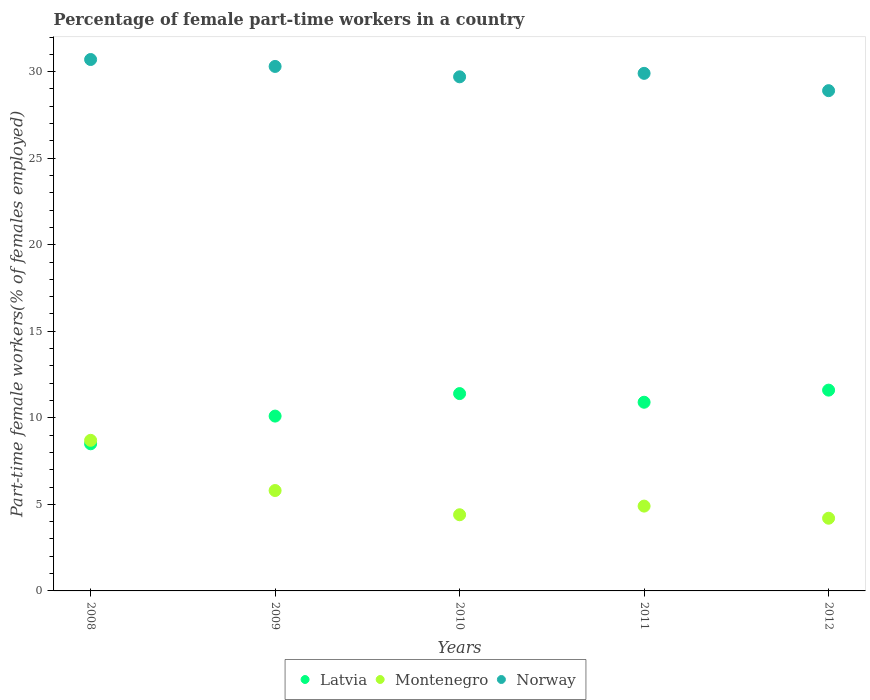How many different coloured dotlines are there?
Keep it short and to the point. 3. Is the number of dotlines equal to the number of legend labels?
Offer a terse response. Yes. What is the percentage of female part-time workers in Latvia in 2012?
Your answer should be compact. 11.6. Across all years, what is the maximum percentage of female part-time workers in Latvia?
Give a very brief answer. 11.6. Across all years, what is the minimum percentage of female part-time workers in Latvia?
Ensure brevity in your answer.  8.5. In which year was the percentage of female part-time workers in Norway minimum?
Give a very brief answer. 2012. What is the total percentage of female part-time workers in Latvia in the graph?
Make the answer very short. 52.5. What is the difference between the percentage of female part-time workers in Norway in 2008 and that in 2011?
Give a very brief answer. 0.8. What is the difference between the percentage of female part-time workers in Montenegro in 2011 and the percentage of female part-time workers in Latvia in 2012?
Give a very brief answer. -6.7. What is the average percentage of female part-time workers in Montenegro per year?
Provide a short and direct response. 5.6. In the year 2008, what is the difference between the percentage of female part-time workers in Norway and percentage of female part-time workers in Latvia?
Your response must be concise. 22.2. What is the ratio of the percentage of female part-time workers in Montenegro in 2008 to that in 2009?
Offer a terse response. 1.5. Is the difference between the percentage of female part-time workers in Norway in 2008 and 2012 greater than the difference between the percentage of female part-time workers in Latvia in 2008 and 2012?
Give a very brief answer. Yes. What is the difference between the highest and the second highest percentage of female part-time workers in Montenegro?
Your response must be concise. 2.9. What is the difference between the highest and the lowest percentage of female part-time workers in Latvia?
Your answer should be very brief. 3.1. Is the sum of the percentage of female part-time workers in Latvia in 2009 and 2010 greater than the maximum percentage of female part-time workers in Montenegro across all years?
Keep it short and to the point. Yes. Is it the case that in every year, the sum of the percentage of female part-time workers in Norway and percentage of female part-time workers in Montenegro  is greater than the percentage of female part-time workers in Latvia?
Provide a succinct answer. Yes. Is the percentage of female part-time workers in Latvia strictly greater than the percentage of female part-time workers in Montenegro over the years?
Provide a short and direct response. No. Is the percentage of female part-time workers in Norway strictly less than the percentage of female part-time workers in Montenegro over the years?
Offer a terse response. No. How many dotlines are there?
Your answer should be compact. 3. What is the difference between two consecutive major ticks on the Y-axis?
Keep it short and to the point. 5. Does the graph contain any zero values?
Provide a succinct answer. No. Does the graph contain grids?
Provide a short and direct response. No. Where does the legend appear in the graph?
Offer a terse response. Bottom center. How are the legend labels stacked?
Offer a terse response. Horizontal. What is the title of the graph?
Give a very brief answer. Percentage of female part-time workers in a country. What is the label or title of the Y-axis?
Give a very brief answer. Part-time female workers(% of females employed). What is the Part-time female workers(% of females employed) in Montenegro in 2008?
Offer a terse response. 8.7. What is the Part-time female workers(% of females employed) in Norway in 2008?
Ensure brevity in your answer.  30.7. What is the Part-time female workers(% of females employed) of Latvia in 2009?
Your answer should be very brief. 10.1. What is the Part-time female workers(% of females employed) in Montenegro in 2009?
Your answer should be very brief. 5.8. What is the Part-time female workers(% of females employed) in Norway in 2009?
Ensure brevity in your answer.  30.3. What is the Part-time female workers(% of females employed) in Latvia in 2010?
Offer a terse response. 11.4. What is the Part-time female workers(% of females employed) in Montenegro in 2010?
Your answer should be very brief. 4.4. What is the Part-time female workers(% of females employed) in Norway in 2010?
Make the answer very short. 29.7. What is the Part-time female workers(% of females employed) in Latvia in 2011?
Provide a short and direct response. 10.9. What is the Part-time female workers(% of females employed) of Montenegro in 2011?
Offer a very short reply. 4.9. What is the Part-time female workers(% of females employed) of Norway in 2011?
Provide a short and direct response. 29.9. What is the Part-time female workers(% of females employed) in Latvia in 2012?
Your response must be concise. 11.6. What is the Part-time female workers(% of females employed) in Montenegro in 2012?
Make the answer very short. 4.2. What is the Part-time female workers(% of females employed) in Norway in 2012?
Your answer should be compact. 28.9. Across all years, what is the maximum Part-time female workers(% of females employed) in Latvia?
Your response must be concise. 11.6. Across all years, what is the maximum Part-time female workers(% of females employed) of Montenegro?
Your answer should be compact. 8.7. Across all years, what is the maximum Part-time female workers(% of females employed) in Norway?
Keep it short and to the point. 30.7. Across all years, what is the minimum Part-time female workers(% of females employed) in Montenegro?
Ensure brevity in your answer.  4.2. Across all years, what is the minimum Part-time female workers(% of females employed) in Norway?
Offer a terse response. 28.9. What is the total Part-time female workers(% of females employed) of Latvia in the graph?
Make the answer very short. 52.5. What is the total Part-time female workers(% of females employed) of Montenegro in the graph?
Give a very brief answer. 28. What is the total Part-time female workers(% of females employed) of Norway in the graph?
Give a very brief answer. 149.5. What is the difference between the Part-time female workers(% of females employed) in Latvia in 2008 and that in 2009?
Provide a succinct answer. -1.6. What is the difference between the Part-time female workers(% of females employed) in Norway in 2008 and that in 2010?
Offer a very short reply. 1. What is the difference between the Part-time female workers(% of females employed) in Latvia in 2008 and that in 2011?
Your answer should be compact. -2.4. What is the difference between the Part-time female workers(% of females employed) of Montenegro in 2008 and that in 2011?
Keep it short and to the point. 3.8. What is the difference between the Part-time female workers(% of females employed) in Latvia in 2008 and that in 2012?
Offer a terse response. -3.1. What is the difference between the Part-time female workers(% of females employed) of Latvia in 2009 and that in 2010?
Your response must be concise. -1.3. What is the difference between the Part-time female workers(% of females employed) of Montenegro in 2009 and that in 2010?
Ensure brevity in your answer.  1.4. What is the difference between the Part-time female workers(% of females employed) of Norway in 2009 and that in 2010?
Your answer should be very brief. 0.6. What is the difference between the Part-time female workers(% of females employed) in Latvia in 2009 and that in 2011?
Ensure brevity in your answer.  -0.8. What is the difference between the Part-time female workers(% of females employed) in Montenegro in 2009 and that in 2011?
Your answer should be very brief. 0.9. What is the difference between the Part-time female workers(% of females employed) of Norway in 2009 and that in 2011?
Give a very brief answer. 0.4. What is the difference between the Part-time female workers(% of females employed) in Latvia in 2009 and that in 2012?
Provide a short and direct response. -1.5. What is the difference between the Part-time female workers(% of females employed) of Norway in 2009 and that in 2012?
Your answer should be very brief. 1.4. What is the difference between the Part-time female workers(% of females employed) of Montenegro in 2010 and that in 2012?
Give a very brief answer. 0.2. What is the difference between the Part-time female workers(% of females employed) in Norway in 2010 and that in 2012?
Provide a succinct answer. 0.8. What is the difference between the Part-time female workers(% of females employed) in Montenegro in 2011 and that in 2012?
Provide a short and direct response. 0.7. What is the difference between the Part-time female workers(% of females employed) of Latvia in 2008 and the Part-time female workers(% of females employed) of Norway in 2009?
Offer a terse response. -21.8. What is the difference between the Part-time female workers(% of females employed) in Montenegro in 2008 and the Part-time female workers(% of females employed) in Norway in 2009?
Your response must be concise. -21.6. What is the difference between the Part-time female workers(% of females employed) of Latvia in 2008 and the Part-time female workers(% of females employed) of Montenegro in 2010?
Ensure brevity in your answer.  4.1. What is the difference between the Part-time female workers(% of females employed) in Latvia in 2008 and the Part-time female workers(% of females employed) in Norway in 2010?
Provide a succinct answer. -21.2. What is the difference between the Part-time female workers(% of females employed) of Montenegro in 2008 and the Part-time female workers(% of females employed) of Norway in 2010?
Offer a terse response. -21. What is the difference between the Part-time female workers(% of females employed) of Latvia in 2008 and the Part-time female workers(% of females employed) of Norway in 2011?
Provide a short and direct response. -21.4. What is the difference between the Part-time female workers(% of females employed) in Montenegro in 2008 and the Part-time female workers(% of females employed) in Norway in 2011?
Ensure brevity in your answer.  -21.2. What is the difference between the Part-time female workers(% of females employed) of Latvia in 2008 and the Part-time female workers(% of females employed) of Norway in 2012?
Your response must be concise. -20.4. What is the difference between the Part-time female workers(% of females employed) of Montenegro in 2008 and the Part-time female workers(% of females employed) of Norway in 2012?
Provide a short and direct response. -20.2. What is the difference between the Part-time female workers(% of females employed) in Latvia in 2009 and the Part-time female workers(% of females employed) in Montenegro in 2010?
Give a very brief answer. 5.7. What is the difference between the Part-time female workers(% of females employed) in Latvia in 2009 and the Part-time female workers(% of females employed) in Norway in 2010?
Your answer should be very brief. -19.6. What is the difference between the Part-time female workers(% of females employed) in Montenegro in 2009 and the Part-time female workers(% of females employed) in Norway in 2010?
Offer a terse response. -23.9. What is the difference between the Part-time female workers(% of females employed) in Latvia in 2009 and the Part-time female workers(% of females employed) in Montenegro in 2011?
Make the answer very short. 5.2. What is the difference between the Part-time female workers(% of females employed) of Latvia in 2009 and the Part-time female workers(% of females employed) of Norway in 2011?
Your response must be concise. -19.8. What is the difference between the Part-time female workers(% of females employed) in Montenegro in 2009 and the Part-time female workers(% of females employed) in Norway in 2011?
Your response must be concise. -24.1. What is the difference between the Part-time female workers(% of females employed) of Latvia in 2009 and the Part-time female workers(% of females employed) of Montenegro in 2012?
Ensure brevity in your answer.  5.9. What is the difference between the Part-time female workers(% of females employed) in Latvia in 2009 and the Part-time female workers(% of females employed) in Norway in 2012?
Provide a succinct answer. -18.8. What is the difference between the Part-time female workers(% of females employed) of Montenegro in 2009 and the Part-time female workers(% of females employed) of Norway in 2012?
Your answer should be compact. -23.1. What is the difference between the Part-time female workers(% of females employed) of Latvia in 2010 and the Part-time female workers(% of females employed) of Montenegro in 2011?
Give a very brief answer. 6.5. What is the difference between the Part-time female workers(% of females employed) of Latvia in 2010 and the Part-time female workers(% of females employed) of Norway in 2011?
Your answer should be compact. -18.5. What is the difference between the Part-time female workers(% of females employed) of Montenegro in 2010 and the Part-time female workers(% of females employed) of Norway in 2011?
Your answer should be compact. -25.5. What is the difference between the Part-time female workers(% of females employed) of Latvia in 2010 and the Part-time female workers(% of females employed) of Norway in 2012?
Offer a very short reply. -17.5. What is the difference between the Part-time female workers(% of females employed) in Montenegro in 2010 and the Part-time female workers(% of females employed) in Norway in 2012?
Your answer should be compact. -24.5. What is the difference between the Part-time female workers(% of females employed) of Latvia in 2011 and the Part-time female workers(% of females employed) of Montenegro in 2012?
Keep it short and to the point. 6.7. What is the difference between the Part-time female workers(% of females employed) in Latvia in 2011 and the Part-time female workers(% of females employed) in Norway in 2012?
Offer a very short reply. -18. What is the difference between the Part-time female workers(% of females employed) in Montenegro in 2011 and the Part-time female workers(% of females employed) in Norway in 2012?
Provide a succinct answer. -24. What is the average Part-time female workers(% of females employed) in Norway per year?
Keep it short and to the point. 29.9. In the year 2008, what is the difference between the Part-time female workers(% of females employed) of Latvia and Part-time female workers(% of females employed) of Norway?
Offer a terse response. -22.2. In the year 2008, what is the difference between the Part-time female workers(% of females employed) of Montenegro and Part-time female workers(% of females employed) of Norway?
Make the answer very short. -22. In the year 2009, what is the difference between the Part-time female workers(% of females employed) of Latvia and Part-time female workers(% of females employed) of Norway?
Offer a very short reply. -20.2. In the year 2009, what is the difference between the Part-time female workers(% of females employed) in Montenegro and Part-time female workers(% of females employed) in Norway?
Make the answer very short. -24.5. In the year 2010, what is the difference between the Part-time female workers(% of females employed) of Latvia and Part-time female workers(% of females employed) of Norway?
Provide a succinct answer. -18.3. In the year 2010, what is the difference between the Part-time female workers(% of females employed) in Montenegro and Part-time female workers(% of females employed) in Norway?
Provide a succinct answer. -25.3. In the year 2011, what is the difference between the Part-time female workers(% of females employed) in Latvia and Part-time female workers(% of females employed) in Norway?
Keep it short and to the point. -19. In the year 2011, what is the difference between the Part-time female workers(% of females employed) of Montenegro and Part-time female workers(% of females employed) of Norway?
Make the answer very short. -25. In the year 2012, what is the difference between the Part-time female workers(% of females employed) in Latvia and Part-time female workers(% of females employed) in Montenegro?
Give a very brief answer. 7.4. In the year 2012, what is the difference between the Part-time female workers(% of females employed) in Latvia and Part-time female workers(% of females employed) in Norway?
Give a very brief answer. -17.3. In the year 2012, what is the difference between the Part-time female workers(% of females employed) in Montenegro and Part-time female workers(% of females employed) in Norway?
Keep it short and to the point. -24.7. What is the ratio of the Part-time female workers(% of females employed) in Latvia in 2008 to that in 2009?
Offer a very short reply. 0.84. What is the ratio of the Part-time female workers(% of females employed) of Montenegro in 2008 to that in 2009?
Your answer should be compact. 1.5. What is the ratio of the Part-time female workers(% of females employed) in Norway in 2008 to that in 2009?
Provide a short and direct response. 1.01. What is the ratio of the Part-time female workers(% of females employed) in Latvia in 2008 to that in 2010?
Ensure brevity in your answer.  0.75. What is the ratio of the Part-time female workers(% of females employed) of Montenegro in 2008 to that in 2010?
Your response must be concise. 1.98. What is the ratio of the Part-time female workers(% of females employed) of Norway in 2008 to that in 2010?
Make the answer very short. 1.03. What is the ratio of the Part-time female workers(% of females employed) in Latvia in 2008 to that in 2011?
Provide a succinct answer. 0.78. What is the ratio of the Part-time female workers(% of females employed) in Montenegro in 2008 to that in 2011?
Provide a succinct answer. 1.78. What is the ratio of the Part-time female workers(% of females employed) of Norway in 2008 to that in 2011?
Keep it short and to the point. 1.03. What is the ratio of the Part-time female workers(% of females employed) of Latvia in 2008 to that in 2012?
Your answer should be compact. 0.73. What is the ratio of the Part-time female workers(% of females employed) of Montenegro in 2008 to that in 2012?
Offer a very short reply. 2.07. What is the ratio of the Part-time female workers(% of females employed) in Norway in 2008 to that in 2012?
Make the answer very short. 1.06. What is the ratio of the Part-time female workers(% of females employed) in Latvia in 2009 to that in 2010?
Give a very brief answer. 0.89. What is the ratio of the Part-time female workers(% of females employed) in Montenegro in 2009 to that in 2010?
Give a very brief answer. 1.32. What is the ratio of the Part-time female workers(% of females employed) in Norway in 2009 to that in 2010?
Your answer should be compact. 1.02. What is the ratio of the Part-time female workers(% of females employed) in Latvia in 2009 to that in 2011?
Your answer should be very brief. 0.93. What is the ratio of the Part-time female workers(% of females employed) of Montenegro in 2009 to that in 2011?
Give a very brief answer. 1.18. What is the ratio of the Part-time female workers(% of females employed) in Norway in 2009 to that in 2011?
Your answer should be very brief. 1.01. What is the ratio of the Part-time female workers(% of females employed) in Latvia in 2009 to that in 2012?
Your response must be concise. 0.87. What is the ratio of the Part-time female workers(% of females employed) in Montenegro in 2009 to that in 2012?
Offer a terse response. 1.38. What is the ratio of the Part-time female workers(% of females employed) of Norway in 2009 to that in 2012?
Make the answer very short. 1.05. What is the ratio of the Part-time female workers(% of females employed) of Latvia in 2010 to that in 2011?
Ensure brevity in your answer.  1.05. What is the ratio of the Part-time female workers(% of females employed) of Montenegro in 2010 to that in 2011?
Provide a succinct answer. 0.9. What is the ratio of the Part-time female workers(% of females employed) of Norway in 2010 to that in 2011?
Your answer should be compact. 0.99. What is the ratio of the Part-time female workers(% of females employed) of Latvia in 2010 to that in 2012?
Ensure brevity in your answer.  0.98. What is the ratio of the Part-time female workers(% of females employed) of Montenegro in 2010 to that in 2012?
Offer a very short reply. 1.05. What is the ratio of the Part-time female workers(% of females employed) in Norway in 2010 to that in 2012?
Your answer should be compact. 1.03. What is the ratio of the Part-time female workers(% of females employed) in Latvia in 2011 to that in 2012?
Ensure brevity in your answer.  0.94. What is the ratio of the Part-time female workers(% of females employed) in Montenegro in 2011 to that in 2012?
Your response must be concise. 1.17. What is the ratio of the Part-time female workers(% of females employed) in Norway in 2011 to that in 2012?
Provide a short and direct response. 1.03. What is the difference between the highest and the second highest Part-time female workers(% of females employed) in Latvia?
Offer a terse response. 0.2. What is the difference between the highest and the second highest Part-time female workers(% of females employed) of Montenegro?
Ensure brevity in your answer.  2.9. What is the difference between the highest and the second highest Part-time female workers(% of females employed) of Norway?
Make the answer very short. 0.4. What is the difference between the highest and the lowest Part-time female workers(% of females employed) in Latvia?
Ensure brevity in your answer.  3.1. What is the difference between the highest and the lowest Part-time female workers(% of females employed) of Norway?
Your response must be concise. 1.8. 